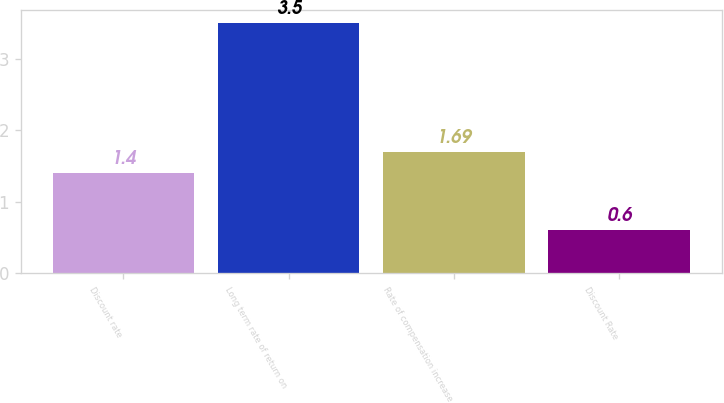Convert chart. <chart><loc_0><loc_0><loc_500><loc_500><bar_chart><fcel>Discount rate<fcel>Long term rate of return on<fcel>Rate of compensation increase<fcel>Discount Rate<nl><fcel>1.4<fcel>3.5<fcel>1.69<fcel>0.6<nl></chart> 